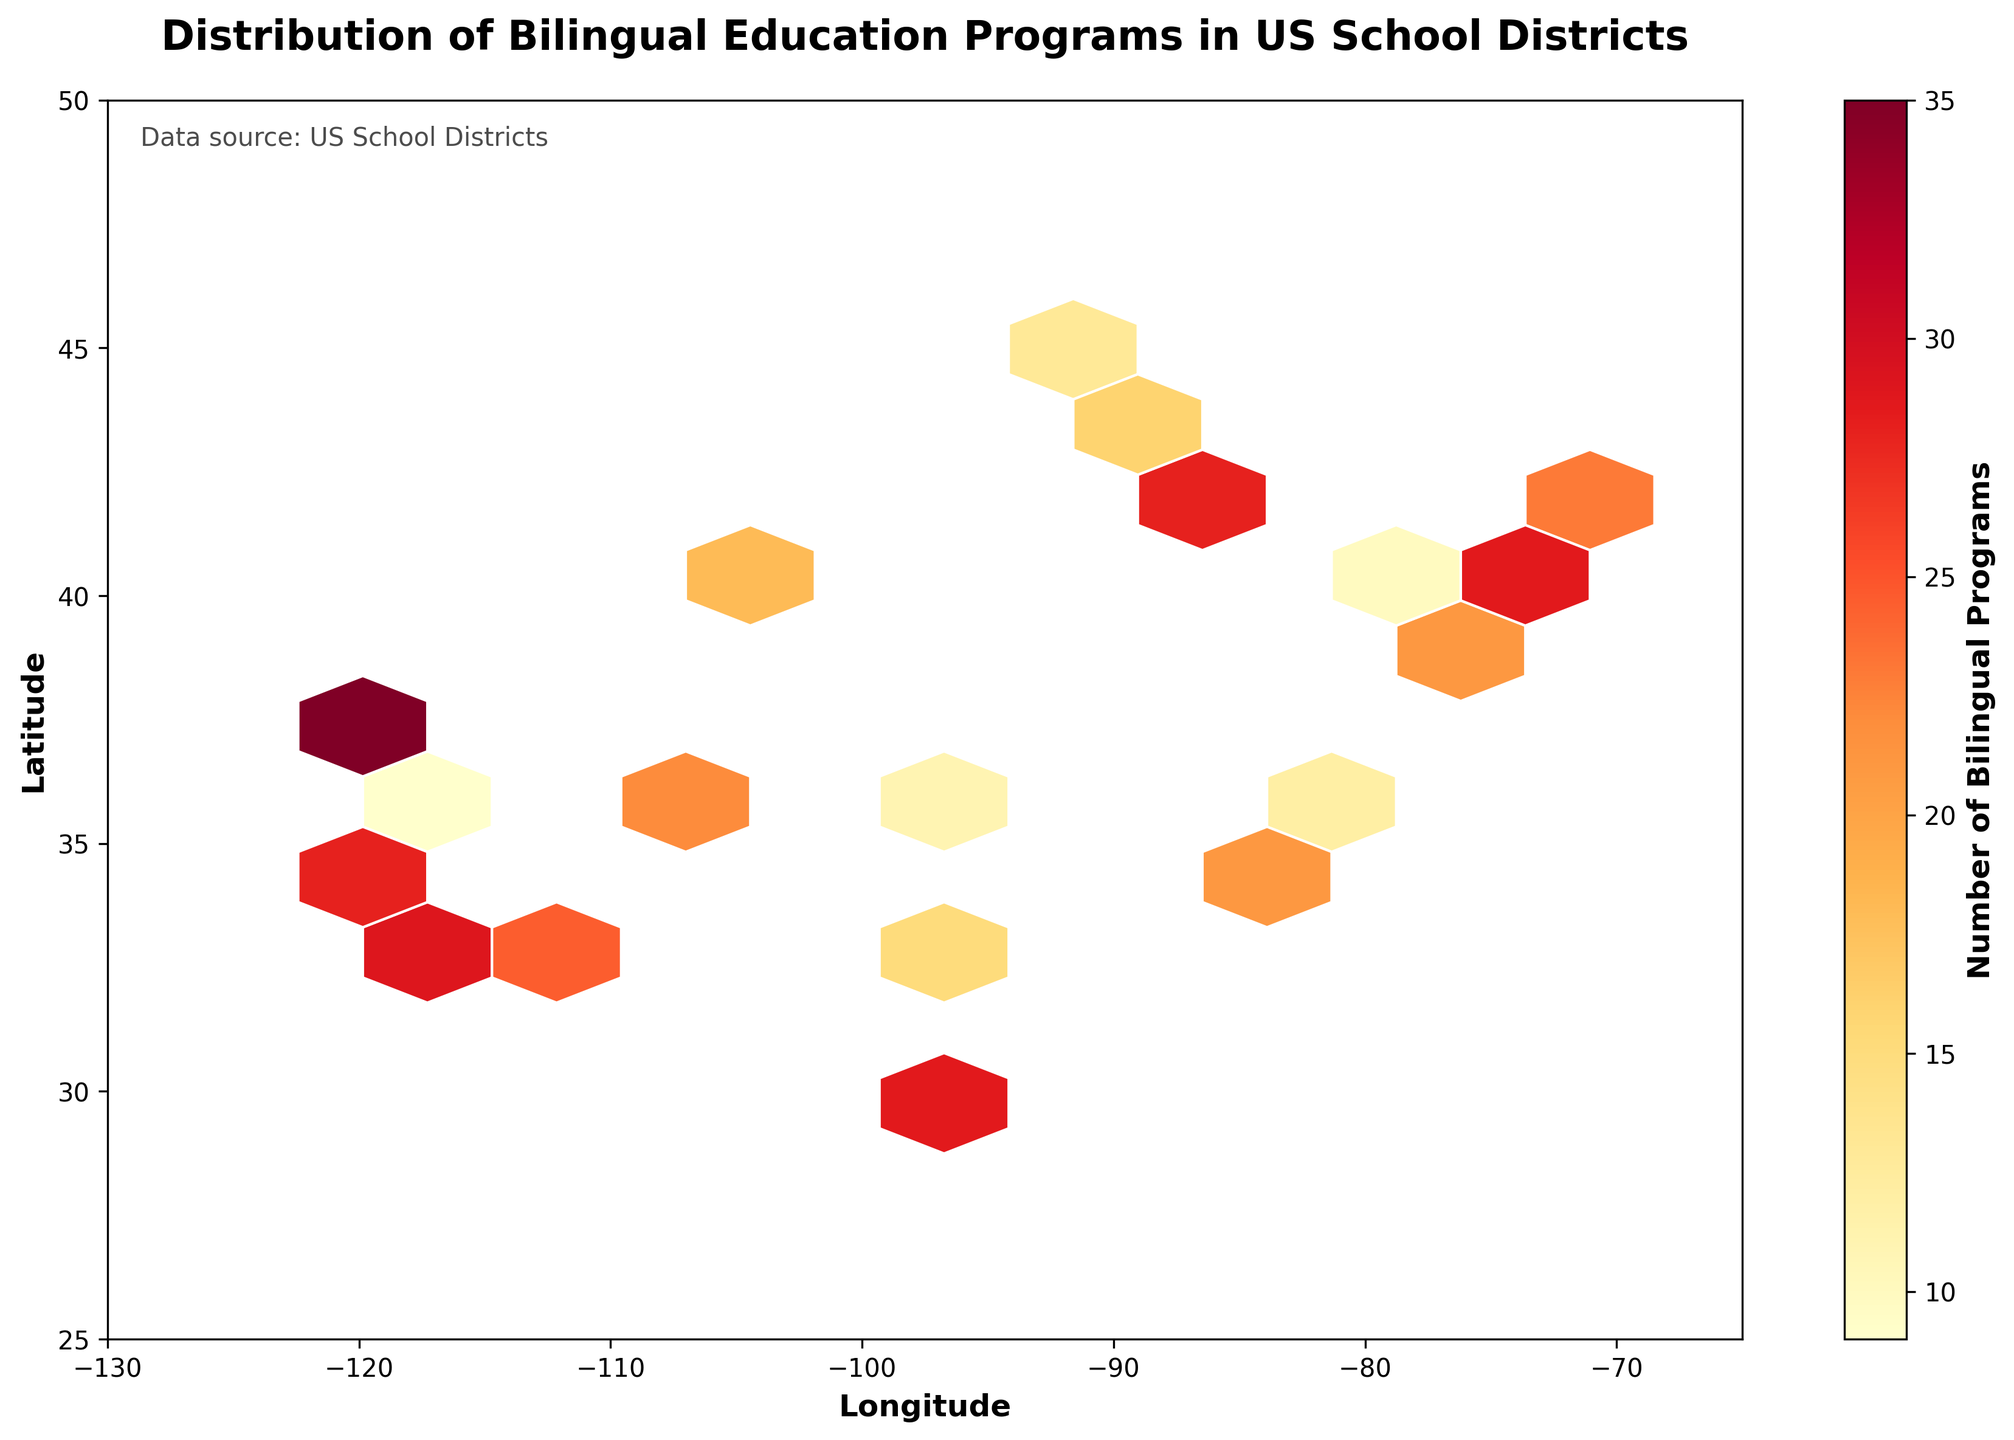What's the title of the figure? The title of the figure is located at the top of the plot and is typically bold and larger in font size compared to other text elements.
Answer: Distribution of Bilingual Education Programs in US School Districts What do the colors in the hexagons represent? The color of each hexagon represents the number of bilingual programs within the geographic area. This is indicated by the color gradient from light yellow to red. The color bar on the right side of the plot shows the corresponding values.
Answer: Number of bilingual programs What is the range of the latitude and longitude axes? The axes ranges are defined by the numerical labels along the x-axis (longitude) and y-axis (latitude). The x-axis ranges from -130 to -65, and the y-axis ranges from 25 to 50.
Answer: Longitude: -130 to -65, Latitude: 25 to 50 Which region in the US shows the highest concentration of bilingual programs based on the hexbin plot? The region with the highest concentration of bilingual programs would correspond to the areas with the darkest red hexagons. Based on the color gradient, the area around Los Angeles (latitude ~34, longitude ~-118) has the highest concentration.
Answer: Area around Los Angeles How many school districts have bilingual programs greater than 30 based on the hexbin colors? By interpreting the color gradient on the hexagons and the color bar, hexagons that are colored similarly to values greater than 30 should be identified. The regions around Los Angeles, New York City, Houston, and San Francisco exhibit this characteristic.
Answer: 4 Is the distribution of bilingual education programs uniform across the US regions shown in the plot? By visually inspecting the hexbin plot, one can see variations in hexagon color density and intensity, indicating that certain regions have higher concentrations of bilingual programs.
Answer: No, the distribution is not uniform What can you infer from the color bar labeled "Number of Bilingual Programs"? The color bar provides a legend that maps colors to numerical values, indicating that darker red hexagons represent a higher number of bilingual programs, while lighter yellow represents fewer programs.
Answer: Darker colors mean more programs Which coast of the US appears to have more bilingual education programs based on the plot? By comparing the east and west coasts visually, we can determine which coast has more dense and darker colored hexagons. The west coast, especially around Los Angeles and San Francisco, appears to have more bilingual programs.
Answer: West coast How does the number of bilingual programs in the central US compare to the coastal regions? Central regions of the US generally have fewer and lighter colored hexagons compared to the coastal regions, indicating fewer bilingual programs.
Answer: Fewer programs in central US What is the maximum value of bilingual programs represented in the plot? The maximum value can be identified from the darkest red hexagons in the plot, as shown in the color bar. The darkest hexagon corresponds to a bilingual program count around 42, which is near Los Angeles.
Answer: 42 